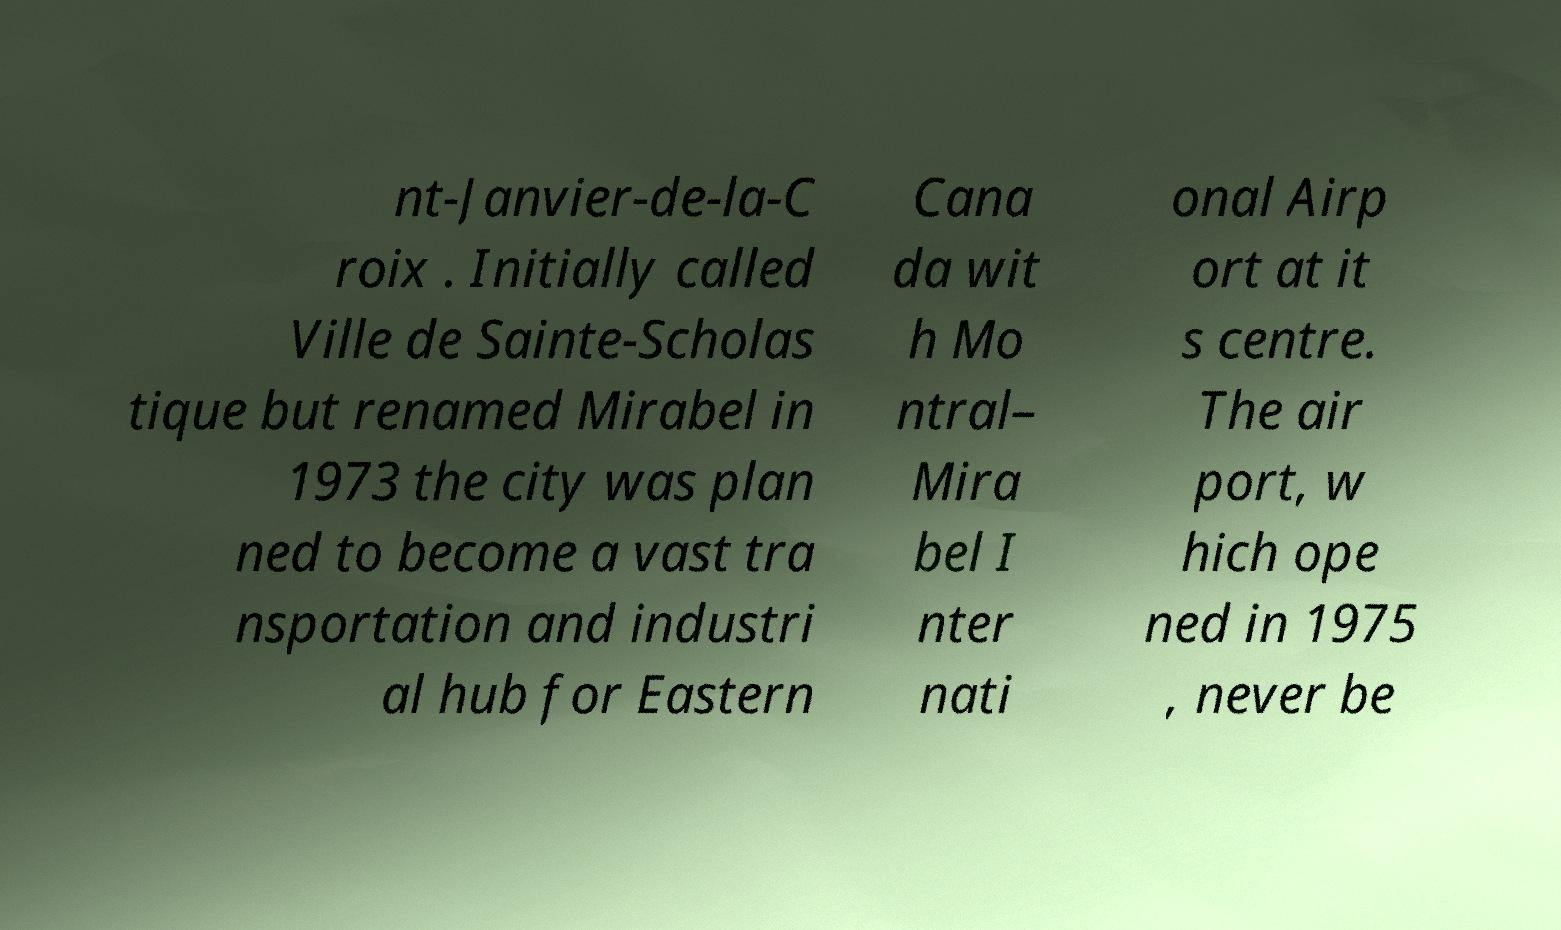Could you assist in decoding the text presented in this image and type it out clearly? nt-Janvier-de-la-C roix . Initially called Ville de Sainte-Scholas tique but renamed Mirabel in 1973 the city was plan ned to become a vast tra nsportation and industri al hub for Eastern Cana da wit h Mo ntral– Mira bel I nter nati onal Airp ort at it s centre. The air port, w hich ope ned in 1975 , never be 